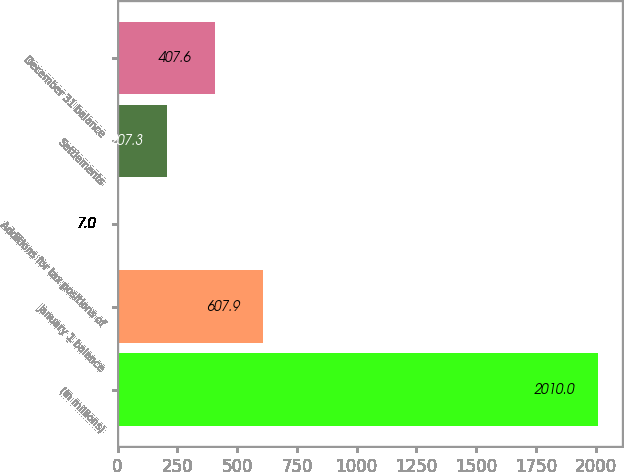Convert chart. <chart><loc_0><loc_0><loc_500><loc_500><bar_chart><fcel>(In millions)<fcel>January 1 balance<fcel>Additions for tax positions of<fcel>Settlements<fcel>December 31 balance<nl><fcel>2010<fcel>607.9<fcel>7<fcel>207.3<fcel>407.6<nl></chart> 